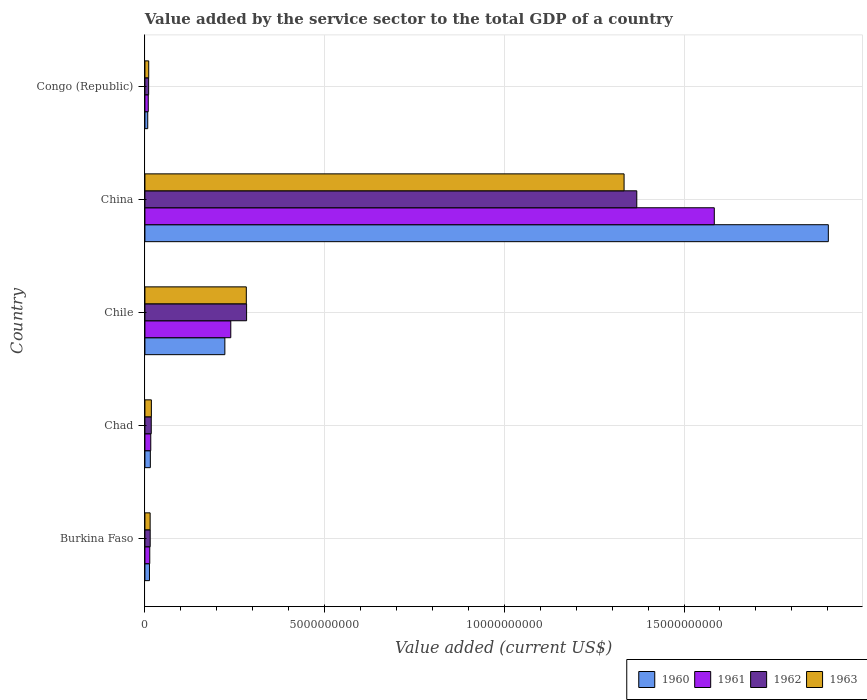How many different coloured bars are there?
Offer a terse response. 4. How many bars are there on the 2nd tick from the bottom?
Offer a very short reply. 4. What is the label of the 5th group of bars from the top?
Give a very brief answer. Burkina Faso. What is the value added by the service sector to the total GDP in 1962 in China?
Make the answer very short. 1.37e+1. Across all countries, what is the maximum value added by the service sector to the total GDP in 1961?
Keep it short and to the point. 1.58e+1. Across all countries, what is the minimum value added by the service sector to the total GDP in 1963?
Provide a short and direct response. 1.06e+08. In which country was the value added by the service sector to the total GDP in 1961 maximum?
Your answer should be very brief. China. In which country was the value added by the service sector to the total GDP in 1961 minimum?
Your answer should be compact. Congo (Republic). What is the total value added by the service sector to the total GDP in 1962 in the graph?
Your answer should be very brief. 1.69e+1. What is the difference between the value added by the service sector to the total GDP in 1961 in Chile and that in Congo (Republic)?
Provide a short and direct response. 2.30e+09. What is the difference between the value added by the service sector to the total GDP in 1963 in Congo (Republic) and the value added by the service sector to the total GDP in 1961 in Burkina Faso?
Provide a succinct answer. -2.92e+07. What is the average value added by the service sector to the total GDP in 1960 per country?
Keep it short and to the point. 4.32e+09. What is the difference between the value added by the service sector to the total GDP in 1962 and value added by the service sector to the total GDP in 1961 in Burkina Faso?
Your answer should be very brief. 1.19e+07. What is the ratio of the value added by the service sector to the total GDP in 1963 in Burkina Faso to that in Congo (Republic)?
Offer a terse response. 1.38. Is the value added by the service sector to the total GDP in 1963 in China less than that in Congo (Republic)?
Offer a very short reply. No. Is the difference between the value added by the service sector to the total GDP in 1962 in China and Congo (Republic) greater than the difference between the value added by the service sector to the total GDP in 1961 in China and Congo (Republic)?
Keep it short and to the point. No. What is the difference between the highest and the second highest value added by the service sector to the total GDP in 1963?
Keep it short and to the point. 1.05e+1. What is the difference between the highest and the lowest value added by the service sector to the total GDP in 1963?
Offer a terse response. 1.32e+1. In how many countries, is the value added by the service sector to the total GDP in 1962 greater than the average value added by the service sector to the total GDP in 1962 taken over all countries?
Make the answer very short. 1. What does the 2nd bar from the top in Chad represents?
Keep it short and to the point. 1962. How many bars are there?
Your answer should be very brief. 20. How many countries are there in the graph?
Provide a short and direct response. 5. What is the difference between two consecutive major ticks on the X-axis?
Your answer should be compact. 5.00e+09. Where does the legend appear in the graph?
Give a very brief answer. Bottom right. What is the title of the graph?
Your response must be concise. Value added by the service sector to the total GDP of a country. What is the label or title of the X-axis?
Your response must be concise. Value added (current US$). What is the label or title of the Y-axis?
Make the answer very short. Country. What is the Value added (current US$) in 1960 in Burkina Faso?
Offer a terse response. 1.26e+08. What is the Value added (current US$) in 1961 in Burkina Faso?
Keep it short and to the point. 1.35e+08. What is the Value added (current US$) of 1962 in Burkina Faso?
Provide a short and direct response. 1.47e+08. What is the Value added (current US$) in 1963 in Burkina Faso?
Offer a very short reply. 1.45e+08. What is the Value added (current US$) in 1960 in Chad?
Offer a terse response. 1.51e+08. What is the Value added (current US$) of 1961 in Chad?
Offer a very short reply. 1.62e+08. What is the Value added (current US$) in 1962 in Chad?
Your response must be concise. 1.76e+08. What is the Value added (current US$) of 1963 in Chad?
Make the answer very short. 1.80e+08. What is the Value added (current US$) in 1960 in Chile?
Your answer should be very brief. 2.22e+09. What is the Value added (current US$) in 1961 in Chile?
Your response must be concise. 2.39e+09. What is the Value added (current US$) in 1962 in Chile?
Ensure brevity in your answer.  2.83e+09. What is the Value added (current US$) of 1963 in Chile?
Provide a succinct answer. 2.82e+09. What is the Value added (current US$) of 1960 in China?
Provide a short and direct response. 1.90e+1. What is the Value added (current US$) of 1961 in China?
Offer a very short reply. 1.58e+1. What is the Value added (current US$) of 1962 in China?
Your answer should be very brief. 1.37e+1. What is the Value added (current US$) in 1963 in China?
Provide a short and direct response. 1.33e+1. What is the Value added (current US$) of 1960 in Congo (Republic)?
Your response must be concise. 7.82e+07. What is the Value added (current US$) of 1961 in Congo (Republic)?
Give a very brief answer. 9.33e+07. What is the Value added (current US$) of 1962 in Congo (Republic)?
Ensure brevity in your answer.  1.04e+08. What is the Value added (current US$) in 1963 in Congo (Republic)?
Provide a succinct answer. 1.06e+08. Across all countries, what is the maximum Value added (current US$) of 1960?
Ensure brevity in your answer.  1.90e+1. Across all countries, what is the maximum Value added (current US$) of 1961?
Give a very brief answer. 1.58e+1. Across all countries, what is the maximum Value added (current US$) in 1962?
Give a very brief answer. 1.37e+1. Across all countries, what is the maximum Value added (current US$) in 1963?
Provide a short and direct response. 1.33e+1. Across all countries, what is the minimum Value added (current US$) in 1960?
Offer a very short reply. 7.82e+07. Across all countries, what is the minimum Value added (current US$) in 1961?
Make the answer very short. 9.33e+07. Across all countries, what is the minimum Value added (current US$) in 1962?
Keep it short and to the point. 1.04e+08. Across all countries, what is the minimum Value added (current US$) in 1963?
Your answer should be compact. 1.06e+08. What is the total Value added (current US$) in 1960 in the graph?
Your answer should be compact. 2.16e+1. What is the total Value added (current US$) of 1961 in the graph?
Provide a short and direct response. 1.86e+1. What is the total Value added (current US$) in 1962 in the graph?
Your answer should be very brief. 1.69e+1. What is the total Value added (current US$) of 1963 in the graph?
Provide a succinct answer. 1.66e+1. What is the difference between the Value added (current US$) of 1960 in Burkina Faso and that in Chad?
Offer a very short reply. -2.45e+07. What is the difference between the Value added (current US$) of 1961 in Burkina Faso and that in Chad?
Make the answer very short. -2.77e+07. What is the difference between the Value added (current US$) in 1962 in Burkina Faso and that in Chad?
Provide a succinct answer. -2.96e+07. What is the difference between the Value added (current US$) of 1963 in Burkina Faso and that in Chad?
Your response must be concise. -3.43e+07. What is the difference between the Value added (current US$) of 1960 in Burkina Faso and that in Chile?
Provide a succinct answer. -2.10e+09. What is the difference between the Value added (current US$) in 1961 in Burkina Faso and that in Chile?
Your response must be concise. -2.25e+09. What is the difference between the Value added (current US$) of 1962 in Burkina Faso and that in Chile?
Offer a terse response. -2.68e+09. What is the difference between the Value added (current US$) in 1963 in Burkina Faso and that in Chile?
Make the answer very short. -2.68e+09. What is the difference between the Value added (current US$) of 1960 in Burkina Faso and that in China?
Ensure brevity in your answer.  -1.89e+1. What is the difference between the Value added (current US$) in 1961 in Burkina Faso and that in China?
Give a very brief answer. -1.57e+1. What is the difference between the Value added (current US$) in 1962 in Burkina Faso and that in China?
Offer a terse response. -1.35e+1. What is the difference between the Value added (current US$) of 1963 in Burkina Faso and that in China?
Provide a succinct answer. -1.32e+1. What is the difference between the Value added (current US$) in 1960 in Burkina Faso and that in Congo (Republic)?
Offer a terse response. 4.82e+07. What is the difference between the Value added (current US$) of 1961 in Burkina Faso and that in Congo (Republic)?
Offer a very short reply. 4.15e+07. What is the difference between the Value added (current US$) of 1962 in Burkina Faso and that in Congo (Republic)?
Your response must be concise. 4.30e+07. What is the difference between the Value added (current US$) in 1963 in Burkina Faso and that in Congo (Republic)?
Keep it short and to the point. 3.98e+07. What is the difference between the Value added (current US$) of 1960 in Chad and that in Chile?
Provide a succinct answer. -2.07e+09. What is the difference between the Value added (current US$) of 1961 in Chad and that in Chile?
Your answer should be compact. -2.23e+09. What is the difference between the Value added (current US$) in 1962 in Chad and that in Chile?
Keep it short and to the point. -2.65e+09. What is the difference between the Value added (current US$) of 1963 in Chad and that in Chile?
Give a very brief answer. -2.64e+09. What is the difference between the Value added (current US$) of 1960 in Chad and that in China?
Your answer should be compact. -1.89e+1. What is the difference between the Value added (current US$) in 1961 in Chad and that in China?
Offer a very short reply. -1.57e+1. What is the difference between the Value added (current US$) in 1962 in Chad and that in China?
Your answer should be very brief. -1.35e+1. What is the difference between the Value added (current US$) in 1963 in Chad and that in China?
Provide a succinct answer. -1.32e+1. What is the difference between the Value added (current US$) in 1960 in Chad and that in Congo (Republic)?
Your answer should be very brief. 7.27e+07. What is the difference between the Value added (current US$) of 1961 in Chad and that in Congo (Republic)?
Ensure brevity in your answer.  6.92e+07. What is the difference between the Value added (current US$) of 1962 in Chad and that in Congo (Republic)?
Your answer should be compact. 7.25e+07. What is the difference between the Value added (current US$) of 1963 in Chad and that in Congo (Republic)?
Your answer should be very brief. 7.41e+07. What is the difference between the Value added (current US$) in 1960 in Chile and that in China?
Your answer should be very brief. -1.68e+1. What is the difference between the Value added (current US$) in 1961 in Chile and that in China?
Your answer should be very brief. -1.35e+1. What is the difference between the Value added (current US$) in 1962 in Chile and that in China?
Offer a terse response. -1.09e+1. What is the difference between the Value added (current US$) in 1963 in Chile and that in China?
Provide a succinct answer. -1.05e+1. What is the difference between the Value added (current US$) in 1960 in Chile and that in Congo (Republic)?
Provide a succinct answer. 2.15e+09. What is the difference between the Value added (current US$) in 1961 in Chile and that in Congo (Republic)?
Keep it short and to the point. 2.30e+09. What is the difference between the Value added (current US$) in 1962 in Chile and that in Congo (Republic)?
Your answer should be very brief. 2.73e+09. What is the difference between the Value added (current US$) of 1963 in Chile and that in Congo (Republic)?
Provide a succinct answer. 2.72e+09. What is the difference between the Value added (current US$) of 1960 in China and that in Congo (Republic)?
Give a very brief answer. 1.89e+1. What is the difference between the Value added (current US$) of 1961 in China and that in Congo (Republic)?
Your response must be concise. 1.57e+1. What is the difference between the Value added (current US$) in 1962 in China and that in Congo (Republic)?
Give a very brief answer. 1.36e+1. What is the difference between the Value added (current US$) in 1963 in China and that in Congo (Republic)?
Make the answer very short. 1.32e+1. What is the difference between the Value added (current US$) of 1960 in Burkina Faso and the Value added (current US$) of 1961 in Chad?
Offer a very short reply. -3.60e+07. What is the difference between the Value added (current US$) in 1960 in Burkina Faso and the Value added (current US$) in 1962 in Chad?
Provide a short and direct response. -4.98e+07. What is the difference between the Value added (current US$) in 1960 in Burkina Faso and the Value added (current US$) in 1963 in Chad?
Your answer should be compact. -5.32e+07. What is the difference between the Value added (current US$) in 1961 in Burkina Faso and the Value added (current US$) in 1962 in Chad?
Your answer should be very brief. -4.15e+07. What is the difference between the Value added (current US$) in 1961 in Burkina Faso and the Value added (current US$) in 1963 in Chad?
Offer a terse response. -4.49e+07. What is the difference between the Value added (current US$) in 1962 in Burkina Faso and the Value added (current US$) in 1963 in Chad?
Provide a succinct answer. -3.29e+07. What is the difference between the Value added (current US$) of 1960 in Burkina Faso and the Value added (current US$) of 1961 in Chile?
Ensure brevity in your answer.  -2.26e+09. What is the difference between the Value added (current US$) in 1960 in Burkina Faso and the Value added (current US$) in 1962 in Chile?
Keep it short and to the point. -2.70e+09. What is the difference between the Value added (current US$) of 1960 in Burkina Faso and the Value added (current US$) of 1963 in Chile?
Make the answer very short. -2.69e+09. What is the difference between the Value added (current US$) in 1961 in Burkina Faso and the Value added (current US$) in 1962 in Chile?
Your answer should be very brief. -2.69e+09. What is the difference between the Value added (current US$) of 1961 in Burkina Faso and the Value added (current US$) of 1963 in Chile?
Your answer should be very brief. -2.69e+09. What is the difference between the Value added (current US$) of 1962 in Burkina Faso and the Value added (current US$) of 1963 in Chile?
Your response must be concise. -2.67e+09. What is the difference between the Value added (current US$) in 1960 in Burkina Faso and the Value added (current US$) in 1961 in China?
Provide a short and direct response. -1.57e+1. What is the difference between the Value added (current US$) of 1960 in Burkina Faso and the Value added (current US$) of 1962 in China?
Keep it short and to the point. -1.36e+1. What is the difference between the Value added (current US$) in 1960 in Burkina Faso and the Value added (current US$) in 1963 in China?
Your answer should be very brief. -1.32e+1. What is the difference between the Value added (current US$) in 1961 in Burkina Faso and the Value added (current US$) in 1962 in China?
Provide a short and direct response. -1.36e+1. What is the difference between the Value added (current US$) in 1961 in Burkina Faso and the Value added (current US$) in 1963 in China?
Make the answer very short. -1.32e+1. What is the difference between the Value added (current US$) of 1962 in Burkina Faso and the Value added (current US$) of 1963 in China?
Your answer should be compact. -1.32e+1. What is the difference between the Value added (current US$) in 1960 in Burkina Faso and the Value added (current US$) in 1961 in Congo (Republic)?
Provide a short and direct response. 3.32e+07. What is the difference between the Value added (current US$) in 1960 in Burkina Faso and the Value added (current US$) in 1962 in Congo (Republic)?
Make the answer very short. 2.27e+07. What is the difference between the Value added (current US$) of 1960 in Burkina Faso and the Value added (current US$) of 1963 in Congo (Republic)?
Your response must be concise. 2.09e+07. What is the difference between the Value added (current US$) in 1961 in Burkina Faso and the Value added (current US$) in 1962 in Congo (Republic)?
Your response must be concise. 3.10e+07. What is the difference between the Value added (current US$) of 1961 in Burkina Faso and the Value added (current US$) of 1963 in Congo (Republic)?
Your answer should be compact. 2.92e+07. What is the difference between the Value added (current US$) in 1962 in Burkina Faso and the Value added (current US$) in 1963 in Congo (Republic)?
Provide a short and direct response. 4.12e+07. What is the difference between the Value added (current US$) in 1960 in Chad and the Value added (current US$) in 1961 in Chile?
Make the answer very short. -2.24e+09. What is the difference between the Value added (current US$) of 1960 in Chad and the Value added (current US$) of 1962 in Chile?
Your response must be concise. -2.68e+09. What is the difference between the Value added (current US$) in 1960 in Chad and the Value added (current US$) in 1963 in Chile?
Give a very brief answer. -2.67e+09. What is the difference between the Value added (current US$) of 1961 in Chad and the Value added (current US$) of 1962 in Chile?
Your answer should be very brief. -2.67e+09. What is the difference between the Value added (current US$) of 1961 in Chad and the Value added (current US$) of 1963 in Chile?
Offer a terse response. -2.66e+09. What is the difference between the Value added (current US$) of 1962 in Chad and the Value added (current US$) of 1963 in Chile?
Your answer should be very brief. -2.64e+09. What is the difference between the Value added (current US$) in 1960 in Chad and the Value added (current US$) in 1961 in China?
Keep it short and to the point. -1.57e+1. What is the difference between the Value added (current US$) in 1960 in Chad and the Value added (current US$) in 1962 in China?
Make the answer very short. -1.35e+1. What is the difference between the Value added (current US$) in 1960 in Chad and the Value added (current US$) in 1963 in China?
Your answer should be very brief. -1.32e+1. What is the difference between the Value added (current US$) in 1961 in Chad and the Value added (current US$) in 1962 in China?
Provide a succinct answer. -1.35e+1. What is the difference between the Value added (current US$) of 1961 in Chad and the Value added (current US$) of 1963 in China?
Ensure brevity in your answer.  -1.32e+1. What is the difference between the Value added (current US$) of 1962 in Chad and the Value added (current US$) of 1963 in China?
Keep it short and to the point. -1.32e+1. What is the difference between the Value added (current US$) of 1960 in Chad and the Value added (current US$) of 1961 in Congo (Republic)?
Provide a short and direct response. 5.77e+07. What is the difference between the Value added (current US$) in 1960 in Chad and the Value added (current US$) in 1962 in Congo (Republic)?
Your answer should be very brief. 4.72e+07. What is the difference between the Value added (current US$) of 1960 in Chad and the Value added (current US$) of 1963 in Congo (Republic)?
Ensure brevity in your answer.  4.54e+07. What is the difference between the Value added (current US$) of 1961 in Chad and the Value added (current US$) of 1962 in Congo (Republic)?
Your answer should be very brief. 5.87e+07. What is the difference between the Value added (current US$) of 1961 in Chad and the Value added (current US$) of 1963 in Congo (Republic)?
Ensure brevity in your answer.  5.69e+07. What is the difference between the Value added (current US$) in 1962 in Chad and the Value added (current US$) in 1963 in Congo (Republic)?
Provide a short and direct response. 7.08e+07. What is the difference between the Value added (current US$) in 1960 in Chile and the Value added (current US$) in 1961 in China?
Offer a very short reply. -1.36e+1. What is the difference between the Value added (current US$) of 1960 in Chile and the Value added (current US$) of 1962 in China?
Ensure brevity in your answer.  -1.15e+1. What is the difference between the Value added (current US$) in 1960 in Chile and the Value added (current US$) in 1963 in China?
Provide a succinct answer. -1.11e+1. What is the difference between the Value added (current US$) of 1961 in Chile and the Value added (current US$) of 1962 in China?
Provide a short and direct response. -1.13e+1. What is the difference between the Value added (current US$) of 1961 in Chile and the Value added (current US$) of 1963 in China?
Offer a very short reply. -1.09e+1. What is the difference between the Value added (current US$) of 1962 in Chile and the Value added (current US$) of 1963 in China?
Provide a short and direct response. -1.05e+1. What is the difference between the Value added (current US$) of 1960 in Chile and the Value added (current US$) of 1961 in Congo (Republic)?
Your response must be concise. 2.13e+09. What is the difference between the Value added (current US$) in 1960 in Chile and the Value added (current US$) in 1962 in Congo (Republic)?
Your response must be concise. 2.12e+09. What is the difference between the Value added (current US$) in 1960 in Chile and the Value added (current US$) in 1963 in Congo (Republic)?
Ensure brevity in your answer.  2.12e+09. What is the difference between the Value added (current US$) in 1961 in Chile and the Value added (current US$) in 1962 in Congo (Republic)?
Your response must be concise. 2.29e+09. What is the difference between the Value added (current US$) in 1961 in Chile and the Value added (current US$) in 1963 in Congo (Republic)?
Your answer should be very brief. 2.28e+09. What is the difference between the Value added (current US$) in 1962 in Chile and the Value added (current US$) in 1963 in Congo (Republic)?
Provide a short and direct response. 2.72e+09. What is the difference between the Value added (current US$) in 1960 in China and the Value added (current US$) in 1961 in Congo (Republic)?
Give a very brief answer. 1.89e+1. What is the difference between the Value added (current US$) of 1960 in China and the Value added (current US$) of 1962 in Congo (Republic)?
Offer a terse response. 1.89e+1. What is the difference between the Value added (current US$) in 1960 in China and the Value added (current US$) in 1963 in Congo (Republic)?
Make the answer very short. 1.89e+1. What is the difference between the Value added (current US$) in 1961 in China and the Value added (current US$) in 1962 in Congo (Republic)?
Offer a terse response. 1.57e+1. What is the difference between the Value added (current US$) in 1961 in China and the Value added (current US$) in 1963 in Congo (Republic)?
Give a very brief answer. 1.57e+1. What is the difference between the Value added (current US$) of 1962 in China and the Value added (current US$) of 1963 in Congo (Republic)?
Keep it short and to the point. 1.36e+1. What is the average Value added (current US$) of 1960 per country?
Provide a succinct answer. 4.32e+09. What is the average Value added (current US$) of 1961 per country?
Ensure brevity in your answer.  3.72e+09. What is the average Value added (current US$) in 1962 per country?
Give a very brief answer. 3.39e+09. What is the average Value added (current US$) of 1963 per country?
Your answer should be very brief. 3.32e+09. What is the difference between the Value added (current US$) in 1960 and Value added (current US$) in 1961 in Burkina Faso?
Provide a short and direct response. -8.32e+06. What is the difference between the Value added (current US$) in 1960 and Value added (current US$) in 1962 in Burkina Faso?
Provide a succinct answer. -2.03e+07. What is the difference between the Value added (current US$) in 1960 and Value added (current US$) in 1963 in Burkina Faso?
Make the answer very short. -1.89e+07. What is the difference between the Value added (current US$) in 1961 and Value added (current US$) in 1962 in Burkina Faso?
Provide a short and direct response. -1.19e+07. What is the difference between the Value added (current US$) in 1961 and Value added (current US$) in 1963 in Burkina Faso?
Offer a very short reply. -1.06e+07. What is the difference between the Value added (current US$) in 1962 and Value added (current US$) in 1963 in Burkina Faso?
Ensure brevity in your answer.  1.38e+06. What is the difference between the Value added (current US$) of 1960 and Value added (current US$) of 1961 in Chad?
Give a very brief answer. -1.15e+07. What is the difference between the Value added (current US$) of 1960 and Value added (current US$) of 1962 in Chad?
Your answer should be compact. -2.53e+07. What is the difference between the Value added (current US$) in 1960 and Value added (current US$) in 1963 in Chad?
Give a very brief answer. -2.87e+07. What is the difference between the Value added (current US$) of 1961 and Value added (current US$) of 1962 in Chad?
Provide a succinct answer. -1.38e+07. What is the difference between the Value added (current US$) in 1961 and Value added (current US$) in 1963 in Chad?
Ensure brevity in your answer.  -1.71e+07. What is the difference between the Value added (current US$) in 1962 and Value added (current US$) in 1963 in Chad?
Ensure brevity in your answer.  -3.34e+06. What is the difference between the Value added (current US$) in 1960 and Value added (current US$) in 1961 in Chile?
Provide a short and direct response. -1.64e+08. What is the difference between the Value added (current US$) of 1960 and Value added (current US$) of 1962 in Chile?
Offer a very short reply. -6.04e+08. What is the difference between the Value added (current US$) of 1960 and Value added (current US$) of 1963 in Chile?
Your response must be concise. -5.96e+08. What is the difference between the Value added (current US$) in 1961 and Value added (current US$) in 1962 in Chile?
Keep it short and to the point. -4.40e+08. What is the difference between the Value added (current US$) of 1961 and Value added (current US$) of 1963 in Chile?
Give a very brief answer. -4.32e+08. What is the difference between the Value added (current US$) in 1962 and Value added (current US$) in 1963 in Chile?
Provide a succinct answer. 8.01e+06. What is the difference between the Value added (current US$) of 1960 and Value added (current US$) of 1961 in China?
Make the answer very short. 3.17e+09. What is the difference between the Value added (current US$) of 1960 and Value added (current US$) of 1962 in China?
Your answer should be compact. 5.33e+09. What is the difference between the Value added (current US$) of 1960 and Value added (current US$) of 1963 in China?
Ensure brevity in your answer.  5.68e+09. What is the difference between the Value added (current US$) of 1961 and Value added (current US$) of 1962 in China?
Your answer should be compact. 2.16e+09. What is the difference between the Value added (current US$) of 1961 and Value added (current US$) of 1963 in China?
Make the answer very short. 2.51e+09. What is the difference between the Value added (current US$) of 1962 and Value added (current US$) of 1963 in China?
Your response must be concise. 3.53e+08. What is the difference between the Value added (current US$) of 1960 and Value added (current US$) of 1961 in Congo (Republic)?
Make the answer very short. -1.51e+07. What is the difference between the Value added (current US$) of 1960 and Value added (current US$) of 1962 in Congo (Republic)?
Keep it short and to the point. -2.55e+07. What is the difference between the Value added (current US$) of 1960 and Value added (current US$) of 1963 in Congo (Republic)?
Keep it short and to the point. -2.73e+07. What is the difference between the Value added (current US$) in 1961 and Value added (current US$) in 1962 in Congo (Republic)?
Your answer should be compact. -1.05e+07. What is the difference between the Value added (current US$) of 1961 and Value added (current US$) of 1963 in Congo (Republic)?
Keep it short and to the point. -1.23e+07. What is the difference between the Value added (current US$) in 1962 and Value added (current US$) in 1963 in Congo (Republic)?
Offer a very short reply. -1.79e+06. What is the ratio of the Value added (current US$) of 1960 in Burkina Faso to that in Chad?
Provide a short and direct response. 0.84. What is the ratio of the Value added (current US$) of 1961 in Burkina Faso to that in Chad?
Keep it short and to the point. 0.83. What is the ratio of the Value added (current US$) in 1962 in Burkina Faso to that in Chad?
Offer a terse response. 0.83. What is the ratio of the Value added (current US$) of 1963 in Burkina Faso to that in Chad?
Your answer should be very brief. 0.81. What is the ratio of the Value added (current US$) in 1960 in Burkina Faso to that in Chile?
Your answer should be very brief. 0.06. What is the ratio of the Value added (current US$) of 1961 in Burkina Faso to that in Chile?
Offer a very short reply. 0.06. What is the ratio of the Value added (current US$) in 1962 in Burkina Faso to that in Chile?
Offer a very short reply. 0.05. What is the ratio of the Value added (current US$) of 1963 in Burkina Faso to that in Chile?
Give a very brief answer. 0.05. What is the ratio of the Value added (current US$) of 1960 in Burkina Faso to that in China?
Your answer should be very brief. 0.01. What is the ratio of the Value added (current US$) of 1961 in Burkina Faso to that in China?
Give a very brief answer. 0.01. What is the ratio of the Value added (current US$) of 1962 in Burkina Faso to that in China?
Your response must be concise. 0.01. What is the ratio of the Value added (current US$) in 1963 in Burkina Faso to that in China?
Your answer should be very brief. 0.01. What is the ratio of the Value added (current US$) of 1960 in Burkina Faso to that in Congo (Republic)?
Your answer should be compact. 1.62. What is the ratio of the Value added (current US$) of 1961 in Burkina Faso to that in Congo (Republic)?
Offer a very short reply. 1.44. What is the ratio of the Value added (current US$) in 1962 in Burkina Faso to that in Congo (Republic)?
Provide a succinct answer. 1.41. What is the ratio of the Value added (current US$) in 1963 in Burkina Faso to that in Congo (Republic)?
Keep it short and to the point. 1.38. What is the ratio of the Value added (current US$) of 1960 in Chad to that in Chile?
Your answer should be very brief. 0.07. What is the ratio of the Value added (current US$) of 1961 in Chad to that in Chile?
Your answer should be compact. 0.07. What is the ratio of the Value added (current US$) in 1962 in Chad to that in Chile?
Give a very brief answer. 0.06. What is the ratio of the Value added (current US$) of 1963 in Chad to that in Chile?
Ensure brevity in your answer.  0.06. What is the ratio of the Value added (current US$) of 1960 in Chad to that in China?
Offer a very short reply. 0.01. What is the ratio of the Value added (current US$) of 1961 in Chad to that in China?
Ensure brevity in your answer.  0.01. What is the ratio of the Value added (current US$) of 1962 in Chad to that in China?
Provide a succinct answer. 0.01. What is the ratio of the Value added (current US$) in 1963 in Chad to that in China?
Provide a short and direct response. 0.01. What is the ratio of the Value added (current US$) in 1960 in Chad to that in Congo (Republic)?
Offer a terse response. 1.93. What is the ratio of the Value added (current US$) of 1961 in Chad to that in Congo (Republic)?
Provide a succinct answer. 1.74. What is the ratio of the Value added (current US$) of 1962 in Chad to that in Congo (Republic)?
Give a very brief answer. 1.7. What is the ratio of the Value added (current US$) in 1963 in Chad to that in Congo (Republic)?
Offer a very short reply. 1.7. What is the ratio of the Value added (current US$) in 1960 in Chile to that in China?
Ensure brevity in your answer.  0.12. What is the ratio of the Value added (current US$) in 1961 in Chile to that in China?
Offer a very short reply. 0.15. What is the ratio of the Value added (current US$) of 1962 in Chile to that in China?
Your answer should be very brief. 0.21. What is the ratio of the Value added (current US$) of 1963 in Chile to that in China?
Keep it short and to the point. 0.21. What is the ratio of the Value added (current US$) of 1960 in Chile to that in Congo (Republic)?
Provide a succinct answer. 28.44. What is the ratio of the Value added (current US$) in 1961 in Chile to that in Congo (Republic)?
Provide a short and direct response. 25.61. What is the ratio of the Value added (current US$) in 1962 in Chile to that in Congo (Republic)?
Make the answer very short. 27.27. What is the ratio of the Value added (current US$) of 1963 in Chile to that in Congo (Republic)?
Provide a succinct answer. 26.73. What is the ratio of the Value added (current US$) of 1960 in China to that in Congo (Republic)?
Offer a very short reply. 243.12. What is the ratio of the Value added (current US$) in 1961 in China to that in Congo (Republic)?
Provide a short and direct response. 169.84. What is the ratio of the Value added (current US$) in 1962 in China to that in Congo (Republic)?
Offer a terse response. 131.91. What is the ratio of the Value added (current US$) in 1963 in China to that in Congo (Republic)?
Your response must be concise. 126.33. What is the difference between the highest and the second highest Value added (current US$) in 1960?
Keep it short and to the point. 1.68e+1. What is the difference between the highest and the second highest Value added (current US$) of 1961?
Ensure brevity in your answer.  1.35e+1. What is the difference between the highest and the second highest Value added (current US$) of 1962?
Ensure brevity in your answer.  1.09e+1. What is the difference between the highest and the second highest Value added (current US$) in 1963?
Make the answer very short. 1.05e+1. What is the difference between the highest and the lowest Value added (current US$) of 1960?
Ensure brevity in your answer.  1.89e+1. What is the difference between the highest and the lowest Value added (current US$) of 1961?
Ensure brevity in your answer.  1.57e+1. What is the difference between the highest and the lowest Value added (current US$) in 1962?
Offer a very short reply. 1.36e+1. What is the difference between the highest and the lowest Value added (current US$) in 1963?
Your answer should be compact. 1.32e+1. 